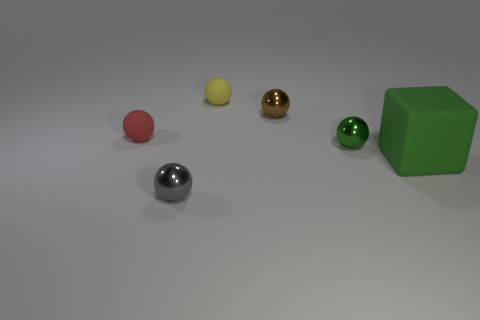Subtract all tiny yellow rubber spheres. How many spheres are left? 4 Subtract all brown balls. How many balls are left? 4 Subtract all balls. How many objects are left? 1 Add 1 tiny gray metallic balls. How many objects exist? 7 Subtract 3 balls. How many balls are left? 2 Subtract all blue blocks. Subtract all brown cylinders. How many blocks are left? 1 Subtract all brown blocks. How many cyan spheres are left? 0 Subtract all tiny gray metallic blocks. Subtract all metal things. How many objects are left? 3 Add 1 small green metallic spheres. How many small green metallic spheres are left? 2 Add 5 tiny objects. How many tiny objects exist? 10 